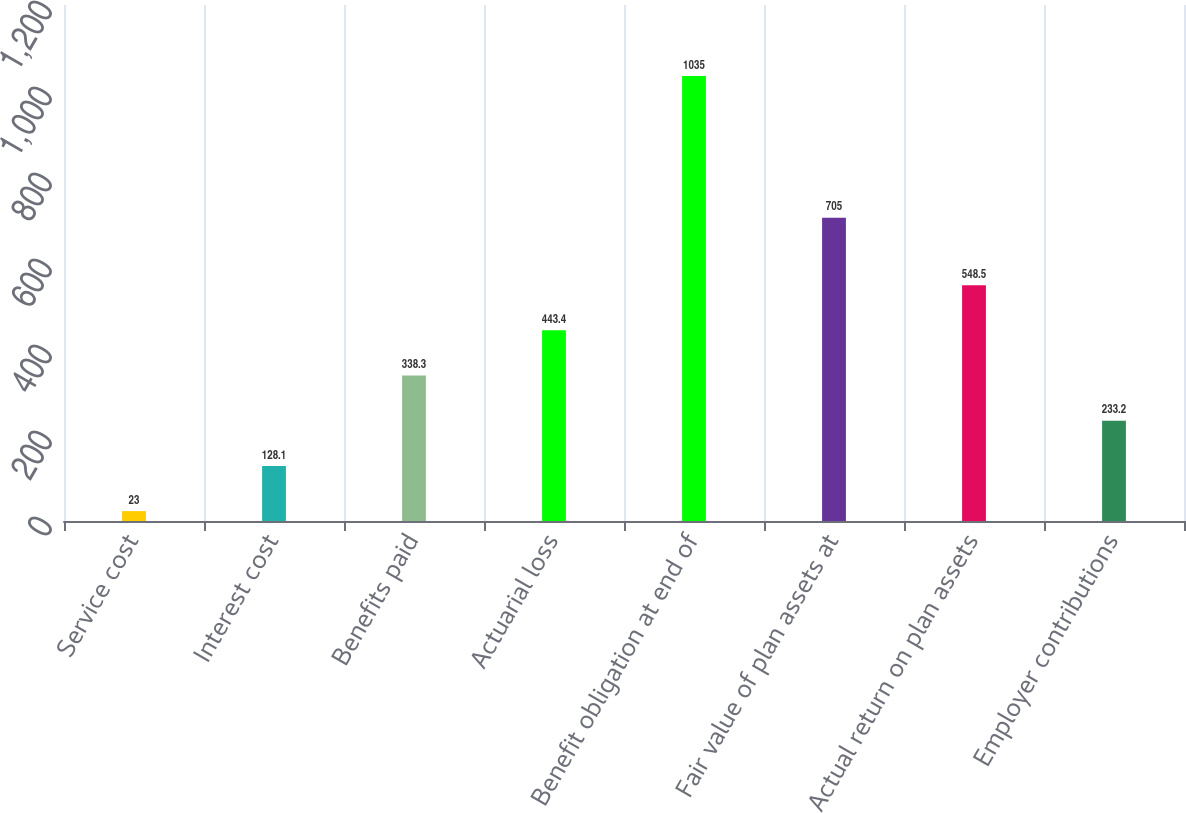Convert chart. <chart><loc_0><loc_0><loc_500><loc_500><bar_chart><fcel>Service cost<fcel>Interest cost<fcel>Benefits paid<fcel>Actuarial loss<fcel>Benefit obligation at end of<fcel>Fair value of plan assets at<fcel>Actual return on plan assets<fcel>Employer contributions<nl><fcel>23<fcel>128.1<fcel>338.3<fcel>443.4<fcel>1035<fcel>705<fcel>548.5<fcel>233.2<nl></chart> 